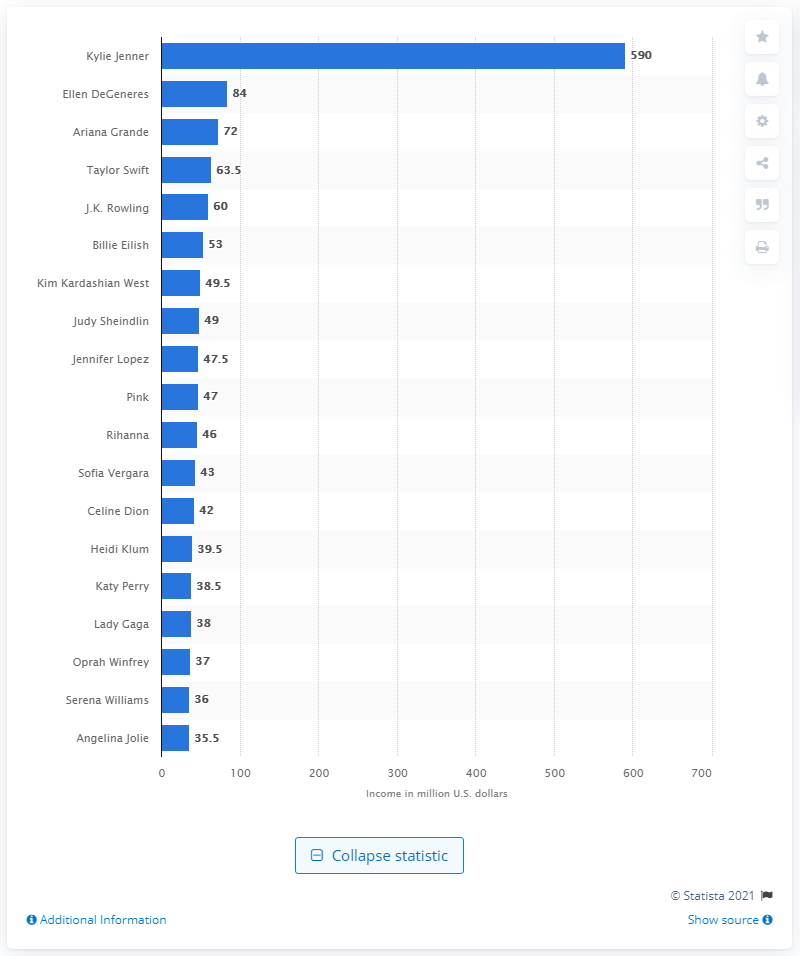Give some essential details in this illustration. Billie Eilish was the newcomer to the Top 100 earners in 2020. Kylie Jenner's annual income was approximately 590 million dollars in 2021. 